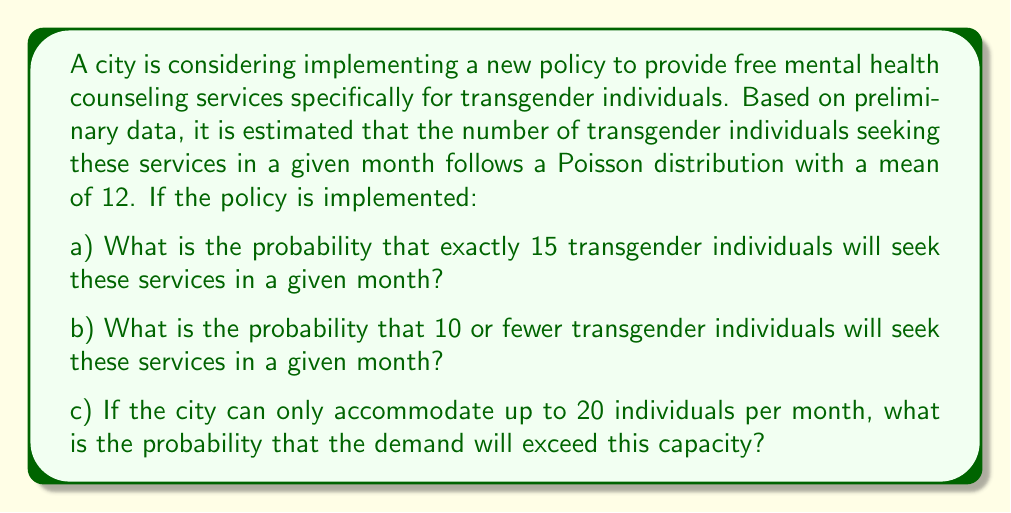Provide a solution to this math problem. To solve this problem, we'll use the Poisson distribution, which is a discrete probability distribution that expresses the probability of a given number of events occurring in a fixed interval of time or space if these events occur with a known constant mean rate and independently of the time since the last event.

The Poisson probability mass function is given by:

$$P(X = k) = \frac{e^{-\lambda} \lambda^k}{k!}$$

Where:
$\lambda$ is the mean number of events in the interval
$k$ is the number of events
$e$ is Euler's number (approximately 2.71828)

In this case, $\lambda = 12$

a) For the probability of exactly 15 individuals:
$$P(X = 15) = \frac{e^{-12} 12^{15}}{15!} \approx 0.0535$$

b) For the probability of 10 or fewer individuals, we need to sum the probabilities from 0 to 10:

$$P(X \leq 10) = \sum_{k=0}^{10} \frac{e^{-12} 12^k}{k!} \approx 0.3472$$

c) For the probability of exceeding 20 individuals, we calculate the probability of 21 or more:

$$P(X > 20) = 1 - P(X \leq 20) = 1 - \sum_{k=0}^{20} \frac{e^{-12} 12^k}{k!} \approx 0.0102$$

These calculations can be performed using statistical software or a calculator with Poisson distribution functions.
Answer: a) $P(X = 15) \approx 0.0535$ or 5.35%
b) $P(X \leq 10) \approx 0.3472$ or 34.72%
c) $P(X > 20) \approx 0.0102$ or 1.02% 